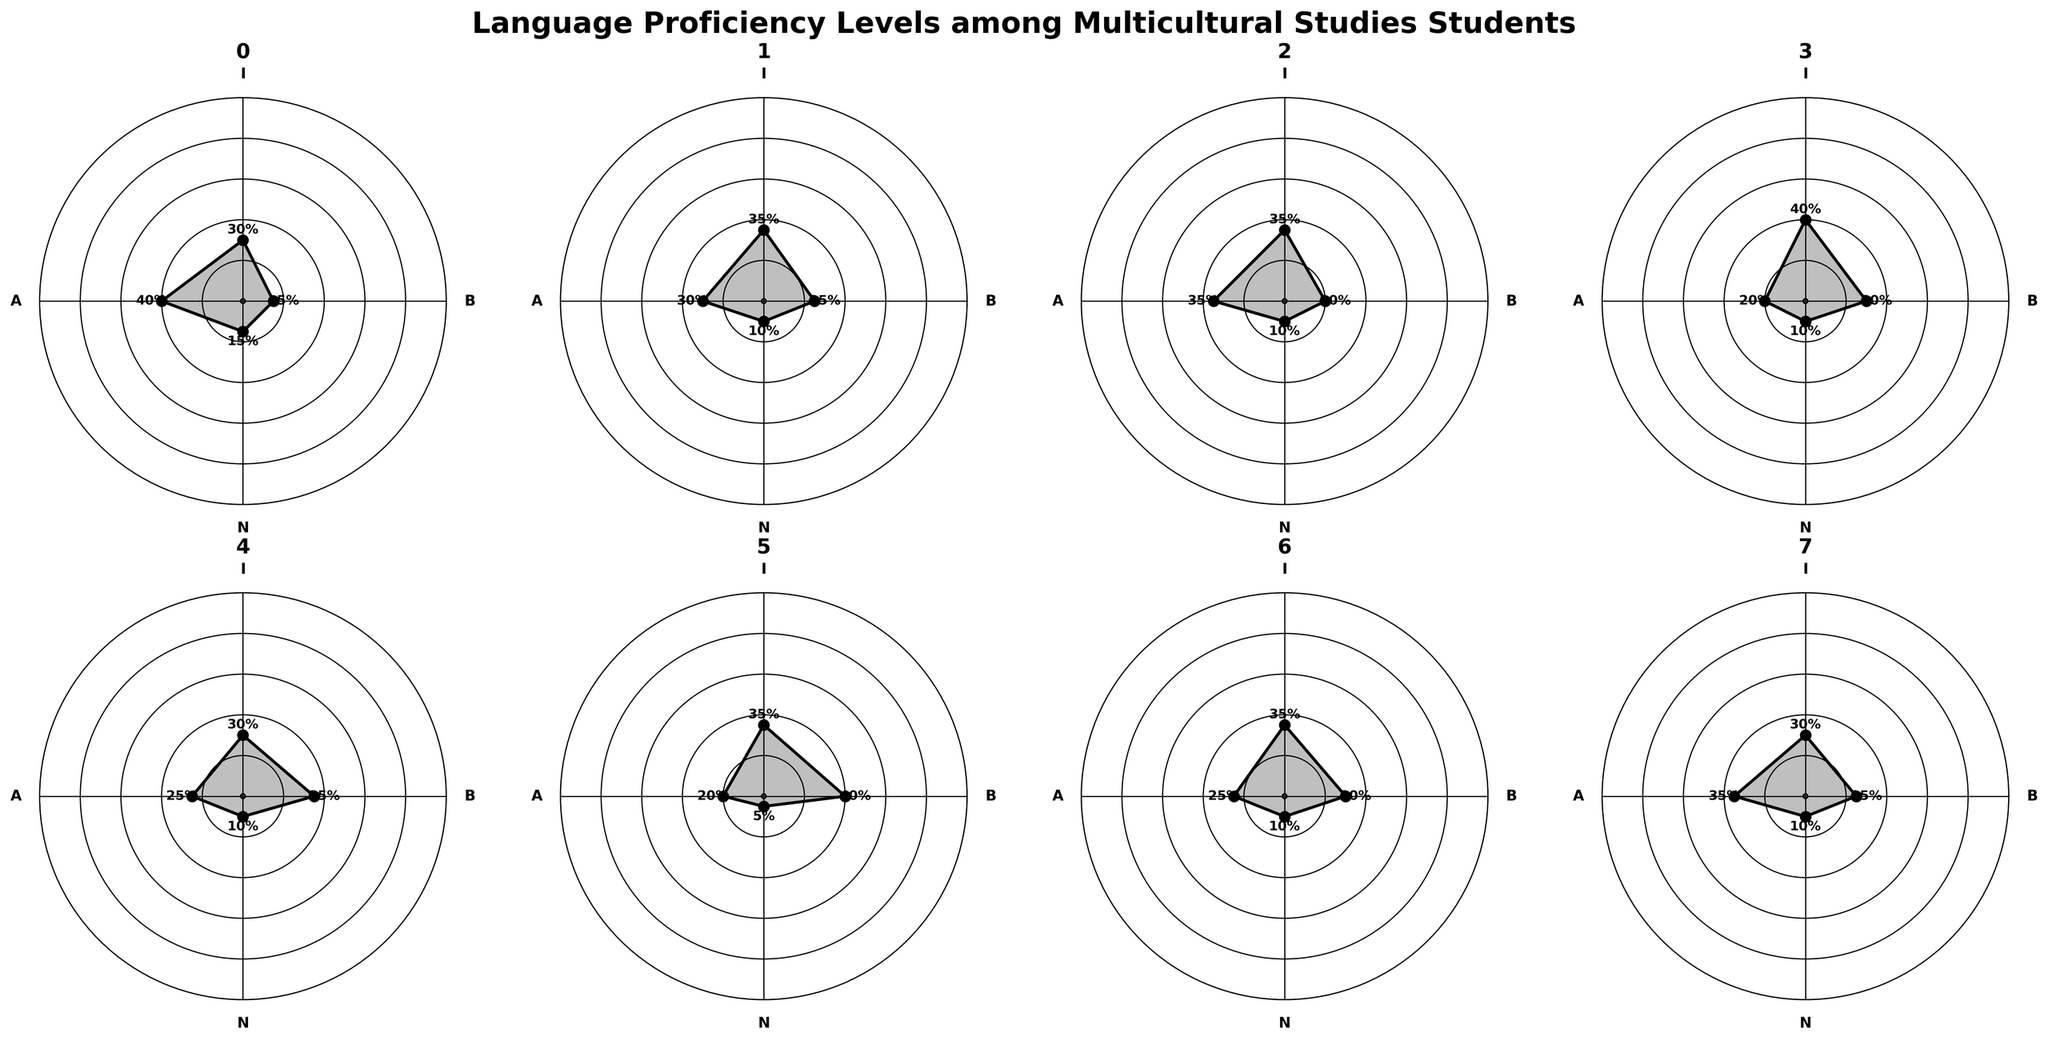What is the title of the figure? The title of the figure is usually placed at the top and is often the largest text. In this case, the title 'Language Proficiency Levels among Multicultural Studies Students' is found at the center-top of the figure.
Answer: Language Proficiency Levels among Multicultural Studies Students What language has the highest percentage of Beginner level proficiency? To find the language with the highest percentage of Beginner level proficiency, look at the data points labeled 'B' for each language and find the one with the highest value. Japanese has the highest value at 35%.
Answer: Japanese Which category has the fewest Native Speakers? To determine which language has the fewest Native Speakers, examine the data points marked 'N'. Swahili has the fewest with 5%.
Answer: Swahili For Arabic, what is the percentage difference between Beginner and Advanced levels? The Beginner level for Arabic is 30%, and the Advanced level is 20%. The difference is obtained by subtracting the smaller value from the larger one: 30% - 20% = 10%.
Answer: 10% Which two languages have the same percentage of Native Speakers? By examining the 'N' data points, you can see that Mandarin, French, Arabic, Japanese, Russian, and Hindi all have 10% Native Speakers.
Answer: Mandarin, French, Arabic, Japanese, Russian, Hindi What's the combined percentage of Intermediate and Advanced levels for Russian? Intermediate for Russian is 35% and Advanced is 25%. Adding these two values gives us 35% + 25% = 60%.
Answer: 60% How does Spanish compare to Mandarin at the Beginner level? Spanish has 15% Beginner proficiency whereas Mandarin has 25%. Mandarin has a higher Beginner proficiency than Spanish.
Answer: Mandarin is higher What is the average percentage of Native Speakers across all languages? Native Speakers values are: Spanish (15%), Mandarin (10%), French (10%), Arabic (10%), Japanese (10%), Swahili (5%), Russian (10%), Hindi (10%). Sum these values: 15 + 10 + 10 + 10 + 10 + 5 + 10 + 10 = 80. Divide by the number of languages (8): 80 / 8 = 10%.
Answer: 10% Which language has the most evenly distributed proficiency levels? Look for the language where the values for Beginner, Intermediate, Advanced, and Native Speaker are closest to each other. French seems to have the most balanced distribution with percentages of 20%, 35%, 35%, and 10% respectively.
Answer: French How many languages have Beginner levels above 25%? The languages are Mandarin (25%), Arabic (30%), Japanese (35%), Swahili (40%), Russian (30%), and Hindi (25%). There are 6 languages.
Answer: 6 